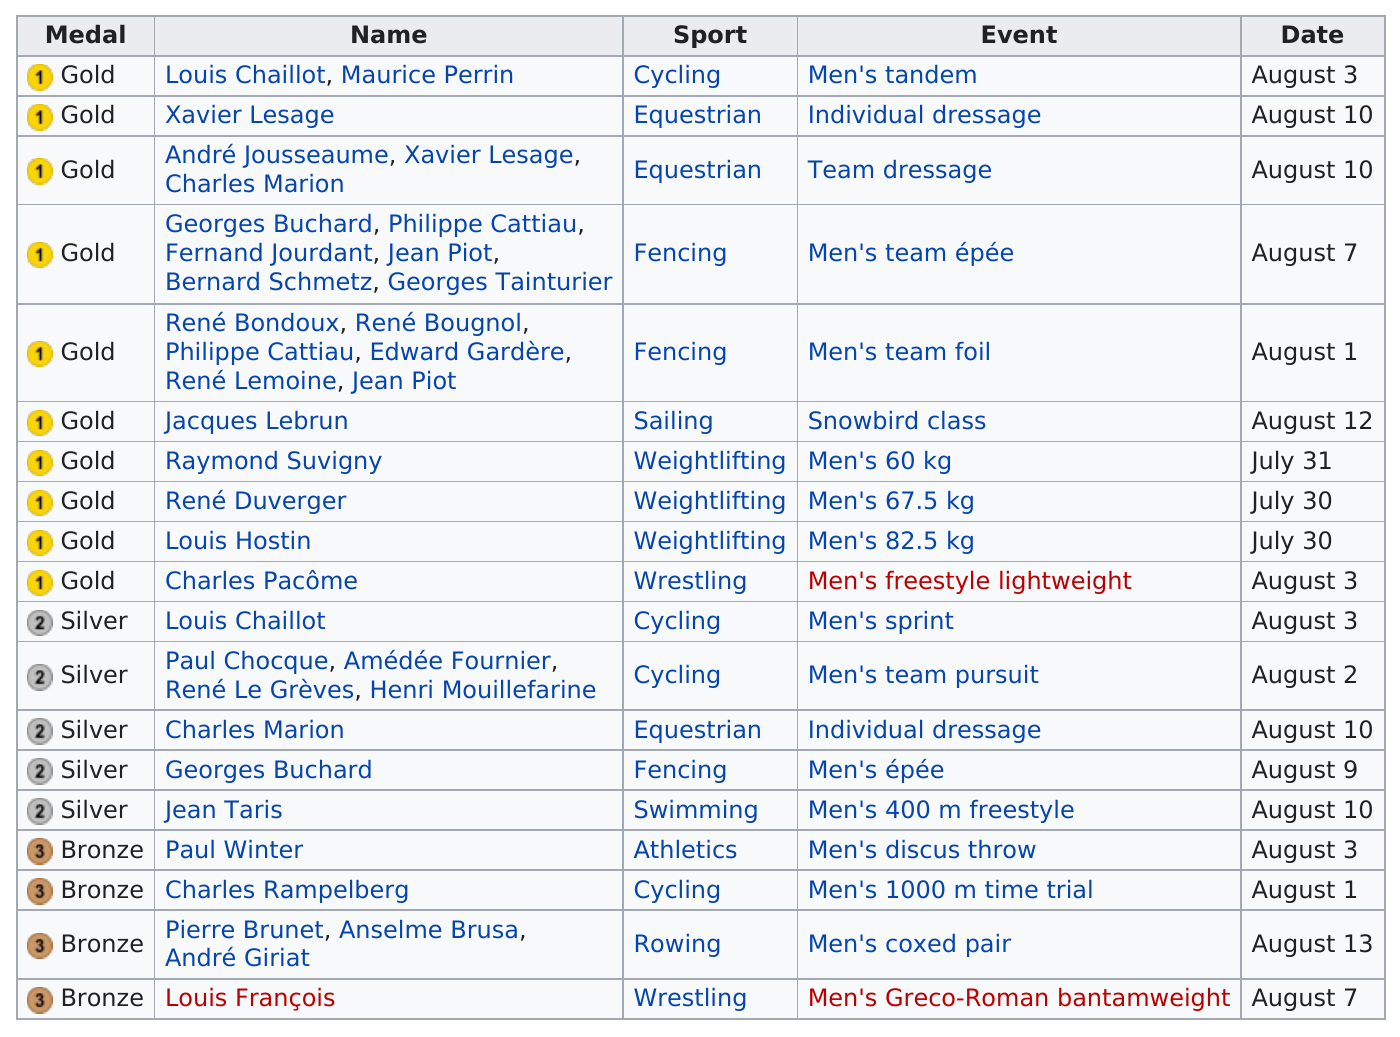Point out several critical features in this image. I, Louis Chaillot, have achieved great success in both cycling and another sport. I have won a gold medal for my outstanding performance in cycling and a silver medal for my exceptional skills in the other sport. The gold medalist won 5 silver medals. During these Olympic Games, this country has won the most medals in sports, with cycling being the top winner. After August 3, a total of 9 medals were won. What is the next date that is listed after August 7th? August 1st. 